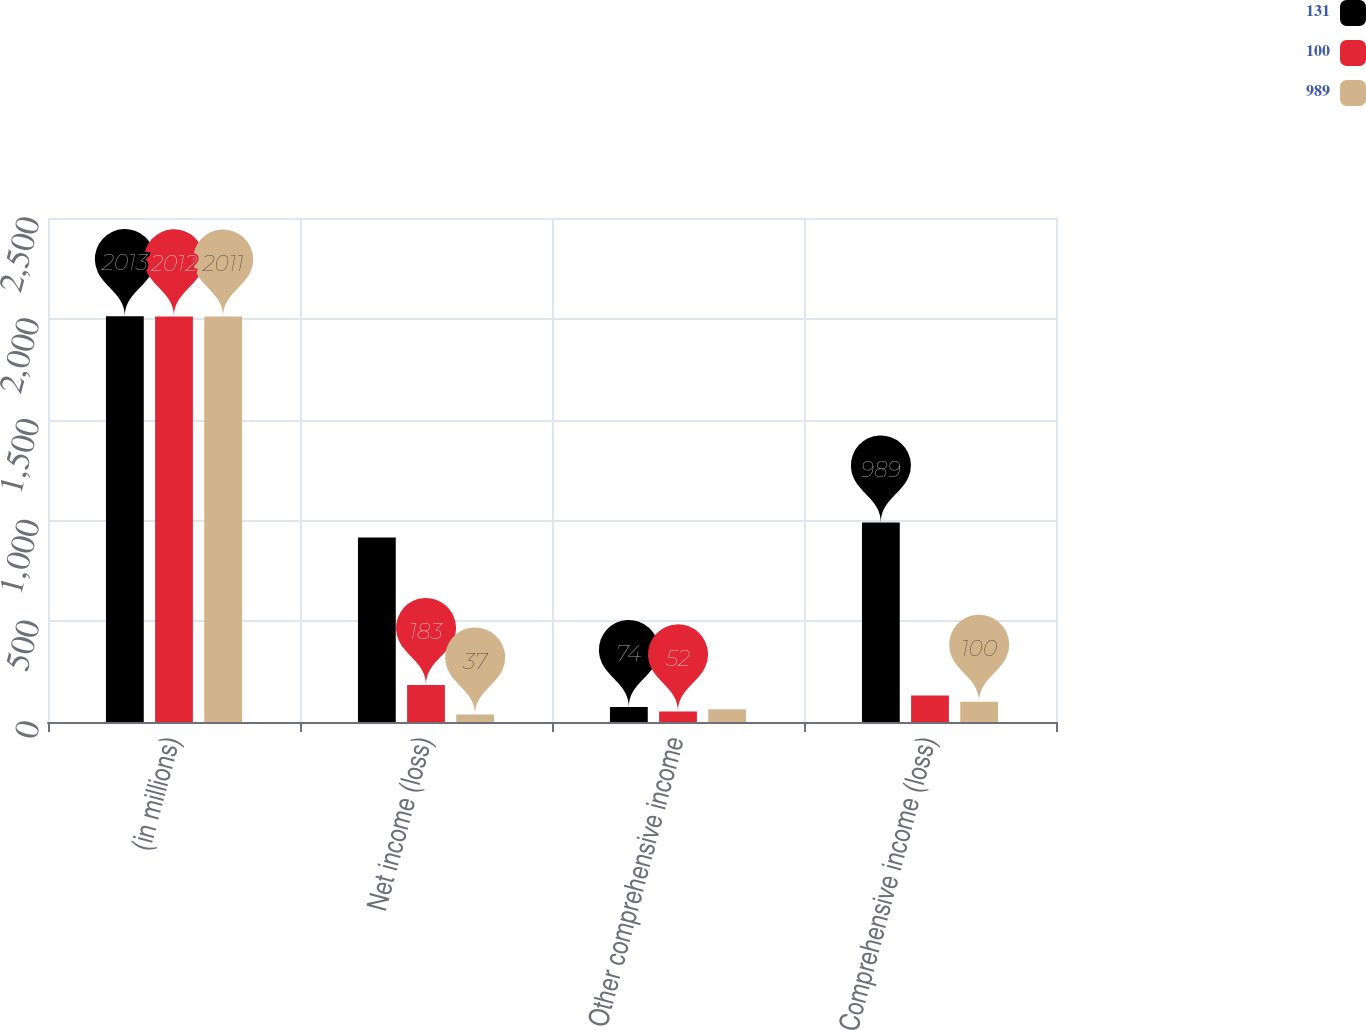Convert chart. <chart><loc_0><loc_0><loc_500><loc_500><stacked_bar_chart><ecel><fcel>(in millions)<fcel>Net income (loss)<fcel>Other comprehensive income<fcel>Comprehensive income (loss)<nl><fcel>131<fcel>2013<fcel>915<fcel>74<fcel>989<nl><fcel>100<fcel>2012<fcel>183<fcel>52<fcel>131<nl><fcel>989<fcel>2011<fcel>37<fcel>63<fcel>100<nl></chart> 